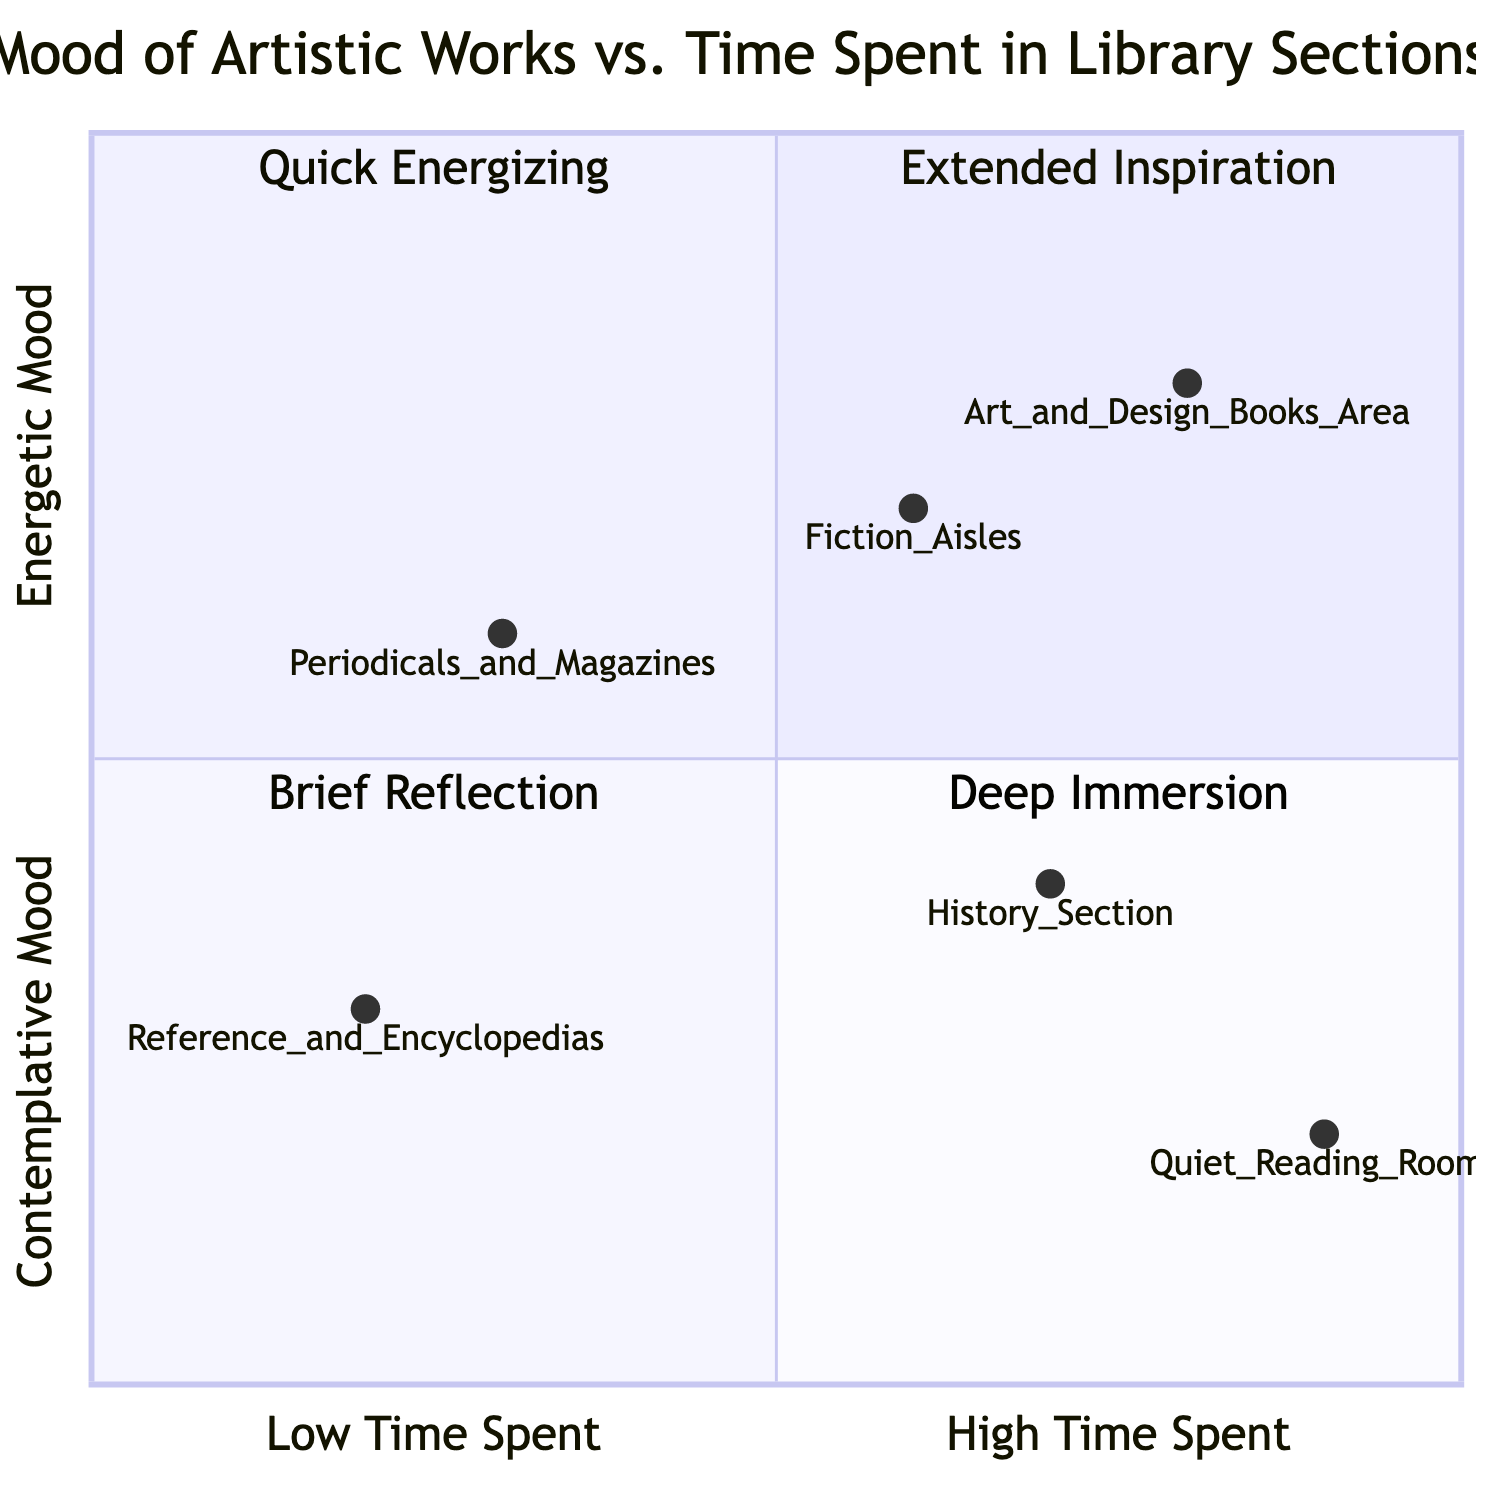What mood is associated with the "Fiction Aisles"? The "Fiction Aisles" are positioned at coordinates [0.6, 0.7]. The y-coordinate indicates a mood leaning towards enthusiasm (higher values represent more energetic moods), which corresponds to excitement. Thus, the mood associated with this section is "Excitement."
Answer: Excitement How much time is typically spent in the "Art and Design Books Area"? The "Art and Design Books Area" is located at [0.8, 0.8]. The x-coordinate of 0.8 suggests a high time spent region, corresponding to Extended Period (more than 45 minutes). Therefore, a lengthy time is typically spent here.
Answer: Extended Period What is the mood of the "Quiet Reading Rooms"? The "Quiet Reading Rooms" are at coordinates [0.9, 0.2]. The low y-coordinate indicates a contemplative mood leaning towards tranquility, which is supported by the low energy reading area. This indicates that the mood in this section is "Tranquility."
Answer: Tranquility Which library section represents the most energizing experience? The quadrant with the highest level of energy and a lower time spent is quadrant 2, indicated as Quick Energizing. Reviewing the sections plotted in this quadrant, the "Fiction Aisles" at [0.6, 0.7] qualifies. Hence, it represents the most energizing experience.
Answer: Fiction Aisles How many sections are categorized as having a deep immersion experience? The quadrant labeled "Deep Immersion" contains sections with extended time spent and higher contemplative moods. By examining the plotted points, only one section, the "Art and Design Books Area" at [0.8, 0.8], fits into this category. Therefore, there is one section in this quadrant.
Answer: 1 Which section has a melancholy mood? To determine which section has a melancholy mood, we look for a point with lower y values indicating a more introspective or contemplative mood. The "Quiet Reading Rooms" falls lower on the mood scale with coordinates [0.9, 0.2], indicating a more reflective area. Therefore, the mood can be classified closer to "Melancholy."
Answer: Quiet Reading Rooms Which section in the diagram is linked to nostalgia? While the diagram doesn't explicitly represent nostalgia, we infer it via the mood range of introspection to melancholy. The "History Section" at [0.7, 0.4] leans more towards introspection, which can be associated indirectly with nostalgia. Thus, it can be concluded that this area speaks to feelings of nostalgia.
Answer: History Section Detect how many sections lie in the "Quick Energizing" quadrant. The quadrant "Quick Energizing" corresponds to lower time spent and higher energy. The analysis shows that the only section plotted in this quadrant is "Fiction Aisles" at [0.6, 0.7]. Thus, there is one section in the "Quick Energizing" quadrant.
Answer: 1 